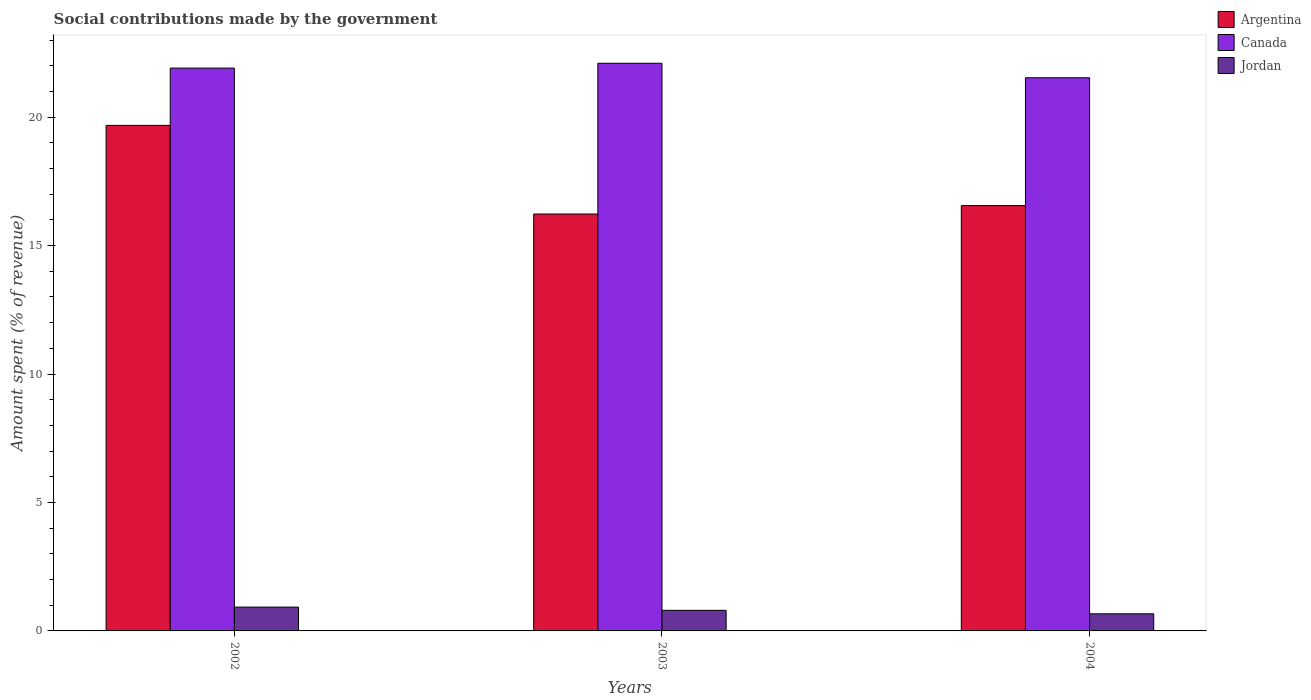Are the number of bars on each tick of the X-axis equal?
Make the answer very short. Yes. How many bars are there on the 1st tick from the right?
Your answer should be compact. 3. What is the label of the 2nd group of bars from the left?
Your response must be concise. 2003. In how many cases, is the number of bars for a given year not equal to the number of legend labels?
Offer a terse response. 0. What is the amount spent (in %) on social contributions in Argentina in 2002?
Offer a terse response. 19.68. Across all years, what is the maximum amount spent (in %) on social contributions in Jordan?
Provide a succinct answer. 0.93. Across all years, what is the minimum amount spent (in %) on social contributions in Jordan?
Provide a succinct answer. 0.67. In which year was the amount spent (in %) on social contributions in Canada maximum?
Your answer should be compact. 2003. In which year was the amount spent (in %) on social contributions in Argentina minimum?
Give a very brief answer. 2003. What is the total amount spent (in %) on social contributions in Canada in the graph?
Your response must be concise. 65.54. What is the difference between the amount spent (in %) on social contributions in Canada in 2003 and that in 2004?
Provide a short and direct response. 0.56. What is the difference between the amount spent (in %) on social contributions in Argentina in 2002 and the amount spent (in %) on social contributions in Canada in 2004?
Your answer should be very brief. -1.85. What is the average amount spent (in %) on social contributions in Canada per year?
Provide a succinct answer. 21.85. In the year 2003, what is the difference between the amount spent (in %) on social contributions in Argentina and amount spent (in %) on social contributions in Jordan?
Make the answer very short. 15.43. In how many years, is the amount spent (in %) on social contributions in Argentina greater than 2 %?
Ensure brevity in your answer.  3. What is the ratio of the amount spent (in %) on social contributions in Jordan in 2003 to that in 2004?
Keep it short and to the point. 1.21. Is the difference between the amount spent (in %) on social contributions in Argentina in 2003 and 2004 greater than the difference between the amount spent (in %) on social contributions in Jordan in 2003 and 2004?
Your response must be concise. No. What is the difference between the highest and the second highest amount spent (in %) on social contributions in Canada?
Offer a terse response. 0.19. What is the difference between the highest and the lowest amount spent (in %) on social contributions in Argentina?
Keep it short and to the point. 3.45. In how many years, is the amount spent (in %) on social contributions in Jordan greater than the average amount spent (in %) on social contributions in Jordan taken over all years?
Ensure brevity in your answer.  2. Is the sum of the amount spent (in %) on social contributions in Argentina in 2003 and 2004 greater than the maximum amount spent (in %) on social contributions in Jordan across all years?
Provide a succinct answer. Yes. What does the 3rd bar from the right in 2002 represents?
Make the answer very short. Argentina. How many bars are there?
Ensure brevity in your answer.  9. Are all the bars in the graph horizontal?
Make the answer very short. No. Does the graph contain any zero values?
Your answer should be very brief. No. What is the title of the graph?
Ensure brevity in your answer.  Social contributions made by the government. What is the label or title of the X-axis?
Keep it short and to the point. Years. What is the label or title of the Y-axis?
Your answer should be very brief. Amount spent (% of revenue). What is the Amount spent (% of revenue) of Argentina in 2002?
Keep it short and to the point. 19.68. What is the Amount spent (% of revenue) in Canada in 2002?
Offer a terse response. 21.91. What is the Amount spent (% of revenue) in Jordan in 2002?
Your answer should be very brief. 0.93. What is the Amount spent (% of revenue) of Argentina in 2003?
Your response must be concise. 16.23. What is the Amount spent (% of revenue) in Canada in 2003?
Give a very brief answer. 22.1. What is the Amount spent (% of revenue) of Jordan in 2003?
Provide a short and direct response. 0.8. What is the Amount spent (% of revenue) of Argentina in 2004?
Your answer should be very brief. 16.56. What is the Amount spent (% of revenue) in Canada in 2004?
Your answer should be compact. 21.53. What is the Amount spent (% of revenue) in Jordan in 2004?
Your answer should be compact. 0.67. Across all years, what is the maximum Amount spent (% of revenue) of Argentina?
Your answer should be compact. 19.68. Across all years, what is the maximum Amount spent (% of revenue) in Canada?
Provide a succinct answer. 22.1. Across all years, what is the maximum Amount spent (% of revenue) in Jordan?
Offer a very short reply. 0.93. Across all years, what is the minimum Amount spent (% of revenue) in Argentina?
Give a very brief answer. 16.23. Across all years, what is the minimum Amount spent (% of revenue) of Canada?
Ensure brevity in your answer.  21.53. Across all years, what is the minimum Amount spent (% of revenue) in Jordan?
Your answer should be compact. 0.67. What is the total Amount spent (% of revenue) in Argentina in the graph?
Your answer should be compact. 52.46. What is the total Amount spent (% of revenue) in Canada in the graph?
Keep it short and to the point. 65.54. What is the total Amount spent (% of revenue) of Jordan in the graph?
Offer a terse response. 2.39. What is the difference between the Amount spent (% of revenue) in Argentina in 2002 and that in 2003?
Make the answer very short. 3.45. What is the difference between the Amount spent (% of revenue) of Canada in 2002 and that in 2003?
Offer a terse response. -0.19. What is the difference between the Amount spent (% of revenue) of Jordan in 2002 and that in 2003?
Ensure brevity in your answer.  0.12. What is the difference between the Amount spent (% of revenue) of Argentina in 2002 and that in 2004?
Give a very brief answer. 3.12. What is the difference between the Amount spent (% of revenue) in Canada in 2002 and that in 2004?
Your response must be concise. 0.38. What is the difference between the Amount spent (% of revenue) of Jordan in 2002 and that in 2004?
Make the answer very short. 0.26. What is the difference between the Amount spent (% of revenue) of Argentina in 2003 and that in 2004?
Offer a terse response. -0.33. What is the difference between the Amount spent (% of revenue) of Canada in 2003 and that in 2004?
Offer a terse response. 0.56. What is the difference between the Amount spent (% of revenue) in Jordan in 2003 and that in 2004?
Keep it short and to the point. 0.14. What is the difference between the Amount spent (% of revenue) in Argentina in 2002 and the Amount spent (% of revenue) in Canada in 2003?
Give a very brief answer. -2.42. What is the difference between the Amount spent (% of revenue) in Argentina in 2002 and the Amount spent (% of revenue) in Jordan in 2003?
Offer a very short reply. 18.88. What is the difference between the Amount spent (% of revenue) of Canada in 2002 and the Amount spent (% of revenue) of Jordan in 2003?
Give a very brief answer. 21.11. What is the difference between the Amount spent (% of revenue) in Argentina in 2002 and the Amount spent (% of revenue) in Canada in 2004?
Ensure brevity in your answer.  -1.85. What is the difference between the Amount spent (% of revenue) of Argentina in 2002 and the Amount spent (% of revenue) of Jordan in 2004?
Make the answer very short. 19.01. What is the difference between the Amount spent (% of revenue) of Canada in 2002 and the Amount spent (% of revenue) of Jordan in 2004?
Give a very brief answer. 21.24. What is the difference between the Amount spent (% of revenue) in Argentina in 2003 and the Amount spent (% of revenue) in Canada in 2004?
Make the answer very short. -5.3. What is the difference between the Amount spent (% of revenue) of Argentina in 2003 and the Amount spent (% of revenue) of Jordan in 2004?
Make the answer very short. 15.56. What is the difference between the Amount spent (% of revenue) of Canada in 2003 and the Amount spent (% of revenue) of Jordan in 2004?
Your answer should be very brief. 21.43. What is the average Amount spent (% of revenue) in Argentina per year?
Your answer should be compact. 17.49. What is the average Amount spent (% of revenue) in Canada per year?
Offer a very short reply. 21.85. What is the average Amount spent (% of revenue) in Jordan per year?
Provide a short and direct response. 0.8. In the year 2002, what is the difference between the Amount spent (% of revenue) of Argentina and Amount spent (% of revenue) of Canada?
Your response must be concise. -2.23. In the year 2002, what is the difference between the Amount spent (% of revenue) in Argentina and Amount spent (% of revenue) in Jordan?
Offer a terse response. 18.75. In the year 2002, what is the difference between the Amount spent (% of revenue) of Canada and Amount spent (% of revenue) of Jordan?
Provide a succinct answer. 20.98. In the year 2003, what is the difference between the Amount spent (% of revenue) in Argentina and Amount spent (% of revenue) in Canada?
Offer a very short reply. -5.87. In the year 2003, what is the difference between the Amount spent (% of revenue) of Argentina and Amount spent (% of revenue) of Jordan?
Offer a very short reply. 15.43. In the year 2003, what is the difference between the Amount spent (% of revenue) of Canada and Amount spent (% of revenue) of Jordan?
Provide a short and direct response. 21.29. In the year 2004, what is the difference between the Amount spent (% of revenue) of Argentina and Amount spent (% of revenue) of Canada?
Make the answer very short. -4.98. In the year 2004, what is the difference between the Amount spent (% of revenue) in Argentina and Amount spent (% of revenue) in Jordan?
Offer a terse response. 15.89. In the year 2004, what is the difference between the Amount spent (% of revenue) of Canada and Amount spent (% of revenue) of Jordan?
Make the answer very short. 20.87. What is the ratio of the Amount spent (% of revenue) in Argentina in 2002 to that in 2003?
Provide a succinct answer. 1.21. What is the ratio of the Amount spent (% of revenue) in Canada in 2002 to that in 2003?
Provide a succinct answer. 0.99. What is the ratio of the Amount spent (% of revenue) of Jordan in 2002 to that in 2003?
Give a very brief answer. 1.16. What is the ratio of the Amount spent (% of revenue) of Argentina in 2002 to that in 2004?
Make the answer very short. 1.19. What is the ratio of the Amount spent (% of revenue) of Canada in 2002 to that in 2004?
Give a very brief answer. 1.02. What is the ratio of the Amount spent (% of revenue) of Jordan in 2002 to that in 2004?
Your answer should be very brief. 1.39. What is the ratio of the Amount spent (% of revenue) in Argentina in 2003 to that in 2004?
Ensure brevity in your answer.  0.98. What is the ratio of the Amount spent (% of revenue) in Canada in 2003 to that in 2004?
Your answer should be compact. 1.03. What is the ratio of the Amount spent (% of revenue) of Jordan in 2003 to that in 2004?
Your response must be concise. 1.21. What is the difference between the highest and the second highest Amount spent (% of revenue) of Argentina?
Offer a terse response. 3.12. What is the difference between the highest and the second highest Amount spent (% of revenue) in Canada?
Offer a terse response. 0.19. What is the difference between the highest and the second highest Amount spent (% of revenue) in Jordan?
Make the answer very short. 0.12. What is the difference between the highest and the lowest Amount spent (% of revenue) in Argentina?
Your answer should be very brief. 3.45. What is the difference between the highest and the lowest Amount spent (% of revenue) in Canada?
Keep it short and to the point. 0.56. What is the difference between the highest and the lowest Amount spent (% of revenue) in Jordan?
Ensure brevity in your answer.  0.26. 